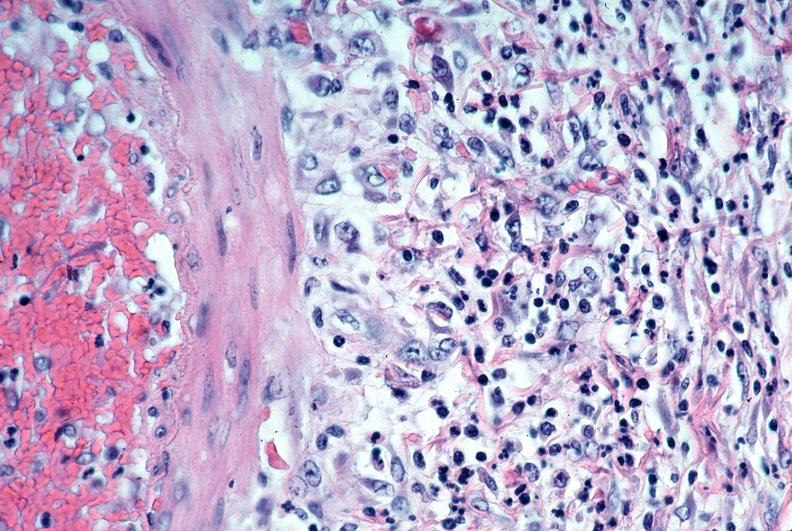does nipple duplication show vasculitis, polyarteritis nodosa?
Answer the question using a single word or phrase. No 